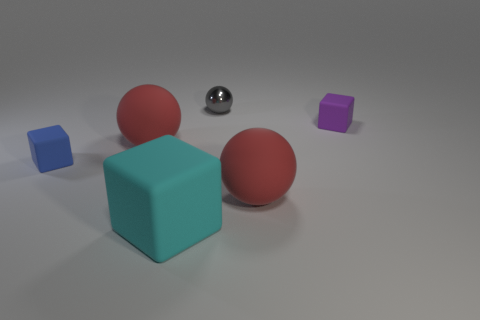What can you infer about the lighting in this scene? The lighting seems to be coming from above as indicated by the shadows under the objects. The shadows are soft-edged, suggesting a diffused light source, likely simulating an overcast sky or soft-box lighting in a studio. 